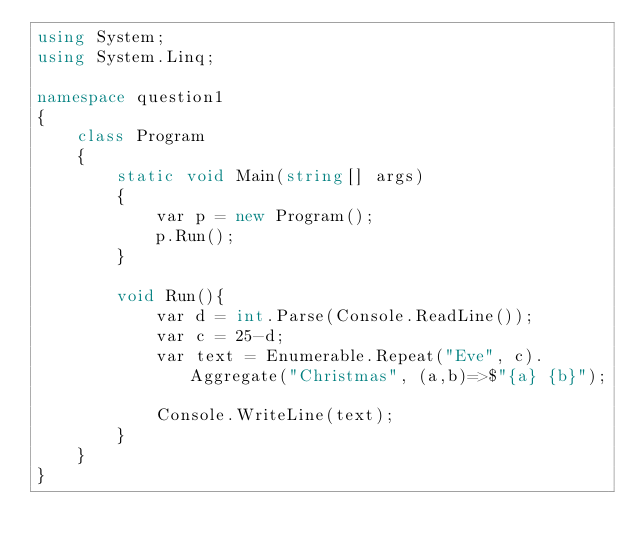Convert code to text. <code><loc_0><loc_0><loc_500><loc_500><_C#_>using System;
using System.Linq;

namespace question1
{
    class Program
    {
        static void Main(string[] args)
        {
            var p = new Program();
            p.Run();
        }

        void Run(){
            var d = int.Parse(Console.ReadLine());
            var c = 25-d;
            var text = Enumerable.Repeat("Eve", c).Aggregate("Christmas", (a,b)=>$"{a} {b}");

            Console.WriteLine(text);
        }
    }
}</code> 